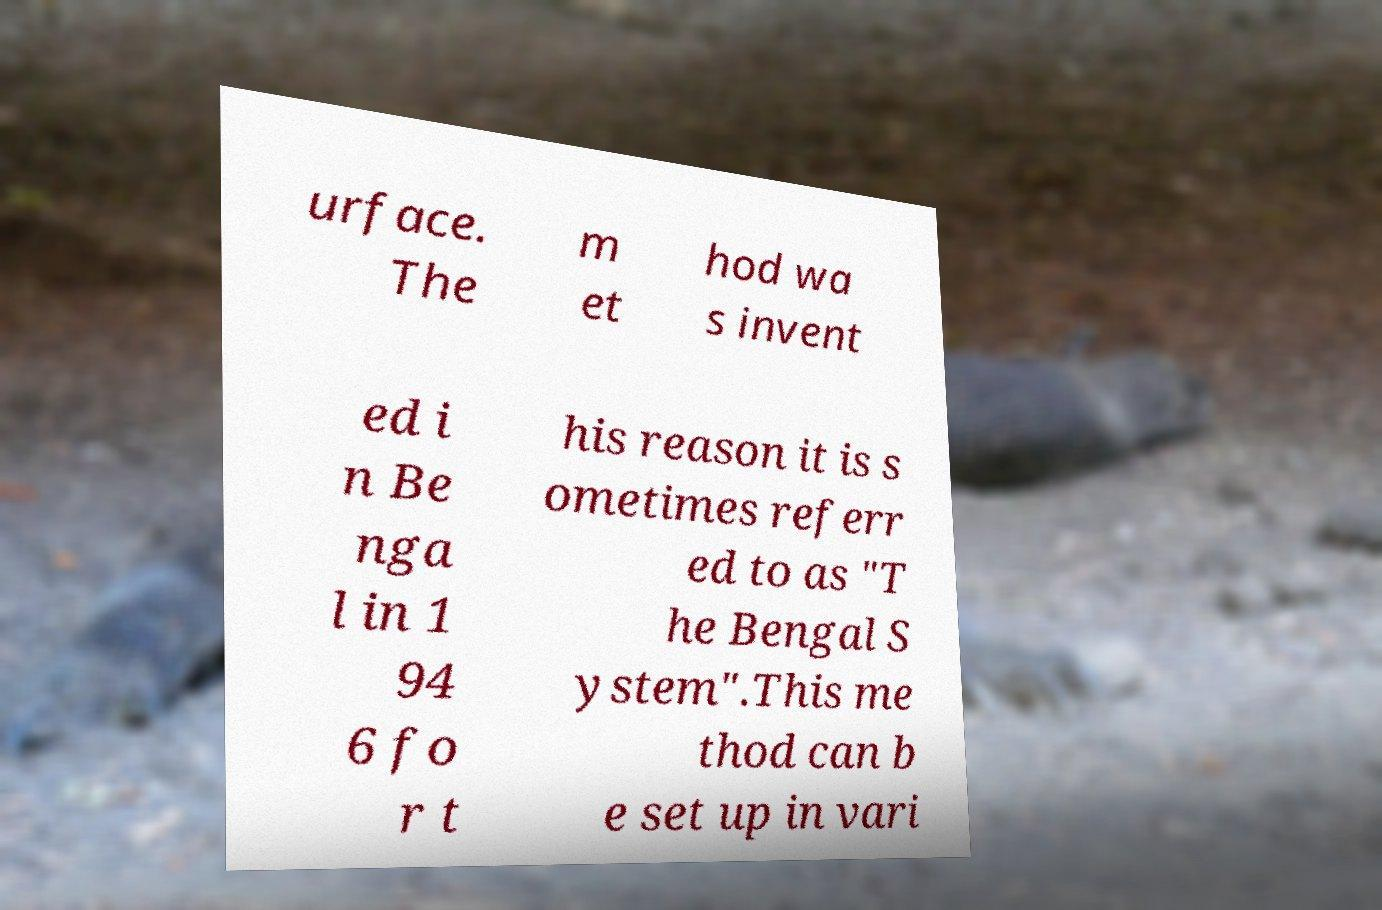Could you extract and type out the text from this image? urface. The m et hod wa s invent ed i n Be nga l in 1 94 6 fo r t his reason it is s ometimes referr ed to as "T he Bengal S ystem".This me thod can b e set up in vari 